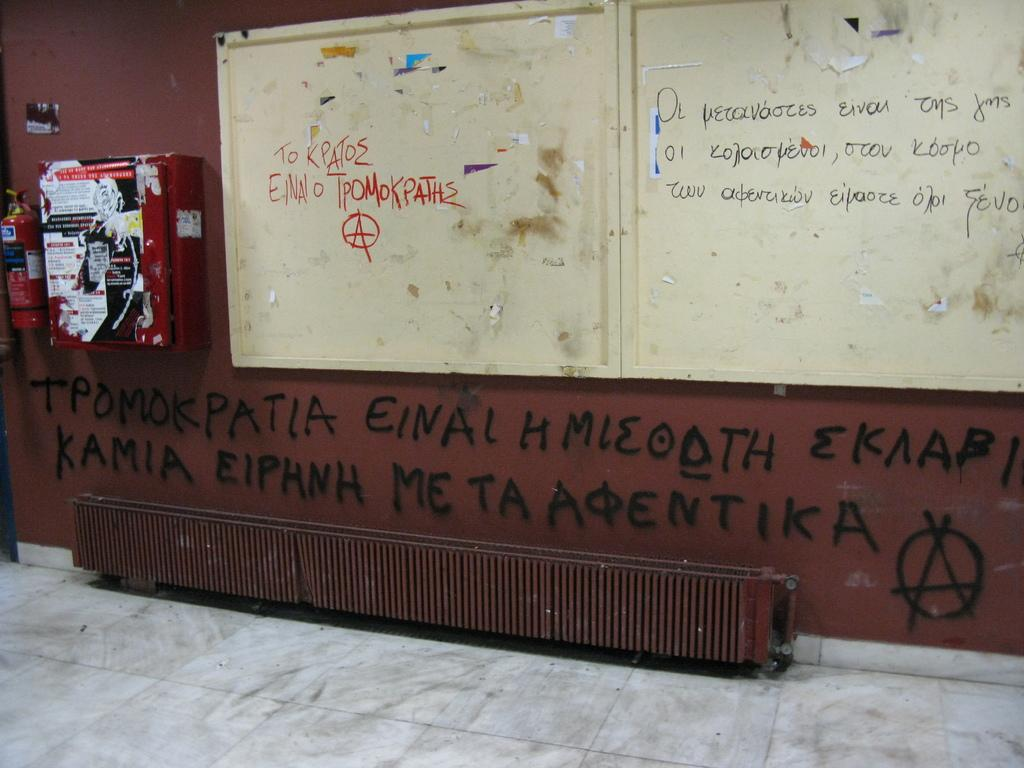<image>
Relay a brief, clear account of the picture shown. The graffiti on this wall begins with the word 'Tpomokpatia'. 